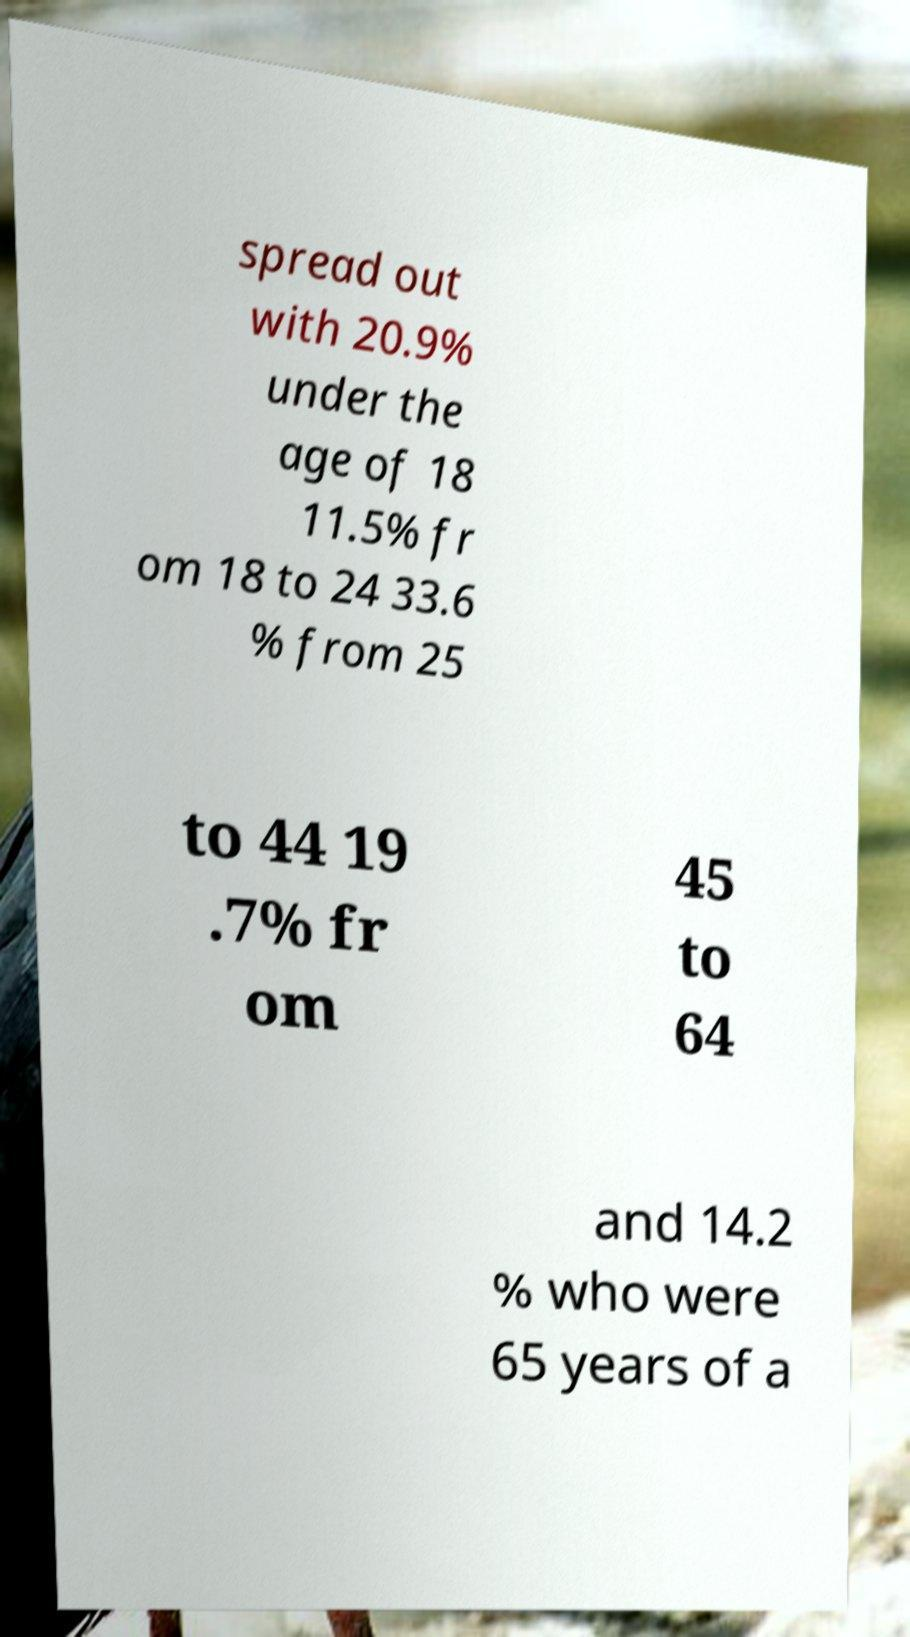There's text embedded in this image that I need extracted. Can you transcribe it verbatim? spread out with 20.9% under the age of 18 11.5% fr om 18 to 24 33.6 % from 25 to 44 19 .7% fr om 45 to 64 and 14.2 % who were 65 years of a 